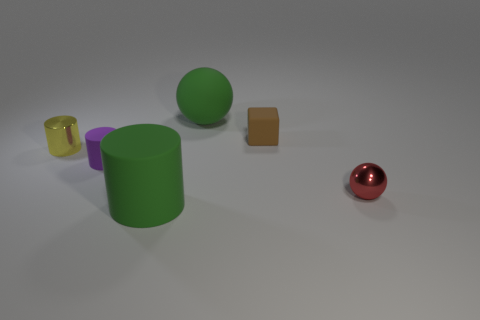What number of other objects are the same material as the block?
Offer a terse response. 3. Is the purple matte cylinder the same size as the rubber ball?
Your answer should be compact. No. What number of things are tiny matte things that are behind the tiny purple matte object or cyan metallic cylinders?
Your answer should be compact. 1. What material is the small yellow cylinder behind the green object in front of the tiny red metallic ball made of?
Your response must be concise. Metal. Is there a small shiny object of the same shape as the purple rubber object?
Keep it short and to the point. Yes. There is a purple cylinder; does it have the same size as the red object that is behind the large matte cylinder?
Provide a succinct answer. Yes. What number of objects are green rubber objects that are in front of the small yellow thing or green objects that are behind the shiny ball?
Give a very brief answer. 2. Is the number of things right of the green ball greater than the number of large gray rubber cubes?
Your response must be concise. Yes. What number of objects have the same size as the rubber cube?
Ensure brevity in your answer.  3. There is a matte cylinder that is behind the green cylinder; is it the same size as the metal object that is in front of the yellow shiny cylinder?
Your answer should be compact. Yes. 